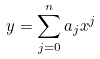<formula> <loc_0><loc_0><loc_500><loc_500>y = \sum _ { j = 0 } ^ { n } a _ { j } x ^ { j }</formula> 